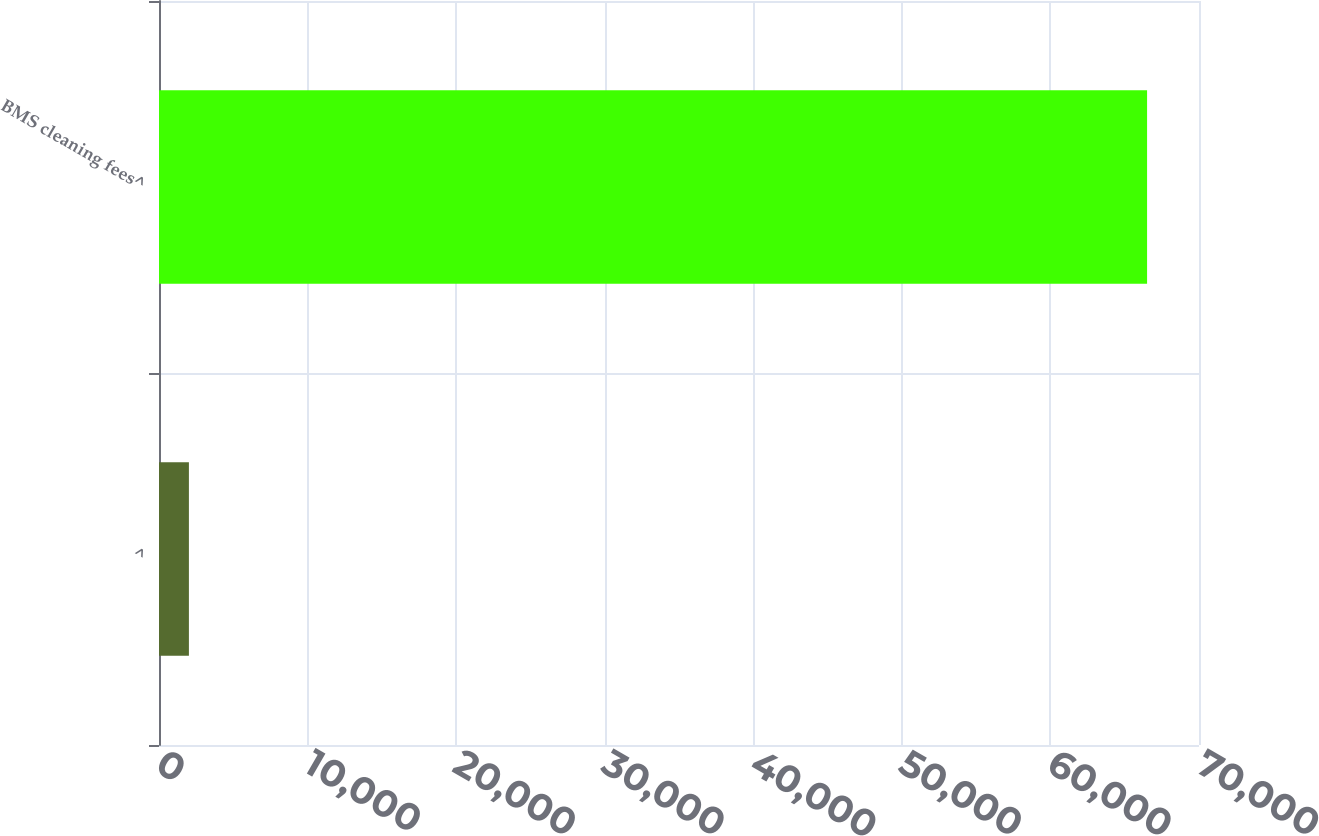<chart> <loc_0><loc_0><loc_500><loc_500><bar_chart><fcel>^<fcel>BMS cleaning fees^<nl><fcel>2013<fcel>66505<nl></chart> 